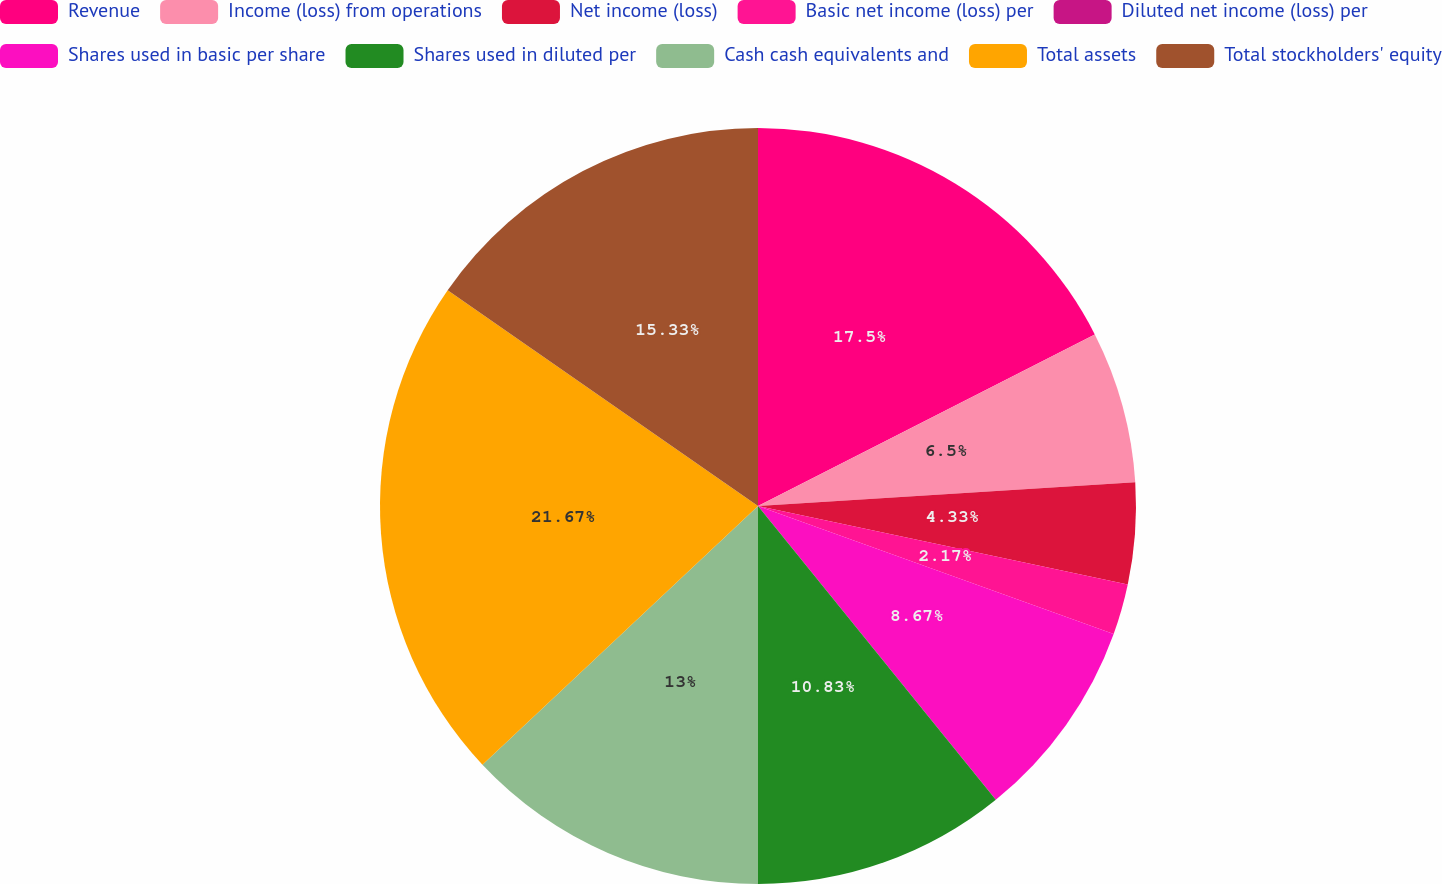<chart> <loc_0><loc_0><loc_500><loc_500><pie_chart><fcel>Revenue<fcel>Income (loss) from operations<fcel>Net income (loss)<fcel>Basic net income (loss) per<fcel>Diluted net income (loss) per<fcel>Shares used in basic per share<fcel>Shares used in diluted per<fcel>Cash cash equivalents and<fcel>Total assets<fcel>Total stockholders' equity<nl><fcel>17.5%<fcel>6.5%<fcel>4.33%<fcel>2.17%<fcel>0.0%<fcel>8.67%<fcel>10.83%<fcel>13.0%<fcel>21.67%<fcel>15.33%<nl></chart> 